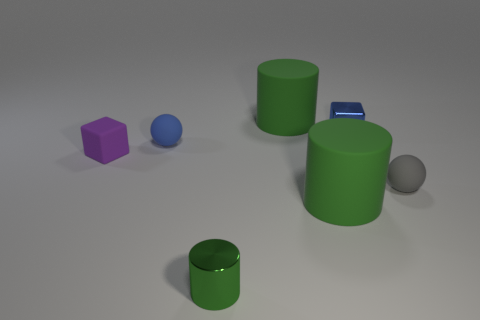How many green cylinders must be subtracted to get 2 green cylinders? 1 Subtract all blocks. How many objects are left? 5 Subtract 1 cylinders. How many cylinders are left? 2 Subtract all blue cylinders. Subtract all gray spheres. How many cylinders are left? 3 Subtract all red balls. How many brown cylinders are left? 0 Subtract all rubber blocks. Subtract all green cylinders. How many objects are left? 3 Add 6 blue shiny blocks. How many blue shiny blocks are left? 7 Add 3 big gray rubber things. How many big gray rubber things exist? 3 Add 3 gray balls. How many objects exist? 10 Subtract all gray spheres. How many spheres are left? 1 